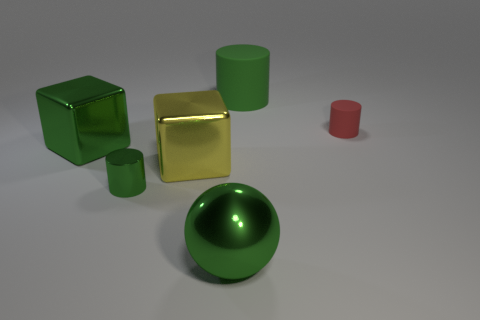Add 2 large green rubber things. How many objects exist? 8 Subtract all balls. How many objects are left? 5 Add 1 large green metallic cubes. How many large green metallic cubes exist? 2 Subtract 0 purple spheres. How many objects are left? 6 Subtract all tiny rubber cylinders. Subtract all metallic balls. How many objects are left? 4 Add 1 tiny green shiny cylinders. How many tiny green shiny cylinders are left? 2 